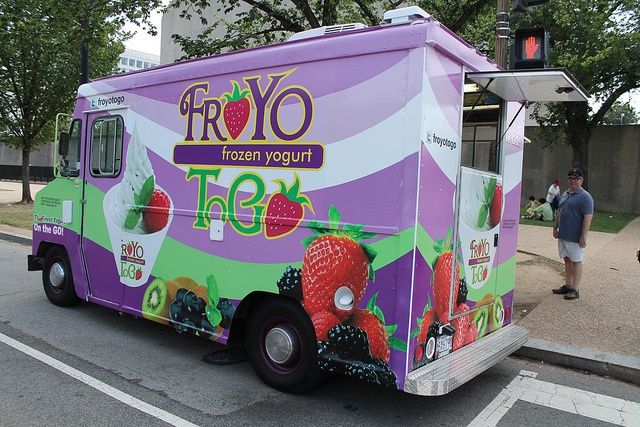Describe the objects in this image and their specific colors. I can see truck in darkgreen, violet, darkgray, and black tones, people in darkgreen, black, gray, and darkgray tones, traffic light in darkgreen, black, gray, salmon, and brown tones, people in darkgreen, black, gray, darkgray, and maroon tones, and people in darkgreen, black, teal, gray, and darkgray tones in this image. 